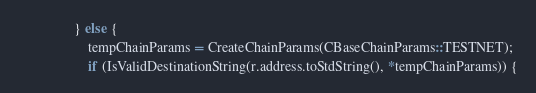Convert code to text. <code><loc_0><loc_0><loc_500><loc_500><_C++_>                } else {
                    tempChainParams = CreateChainParams(CBaseChainParams::TESTNET);
                    if (IsValidDestinationString(r.address.toStdString(), *tempChainParams)) {</code> 